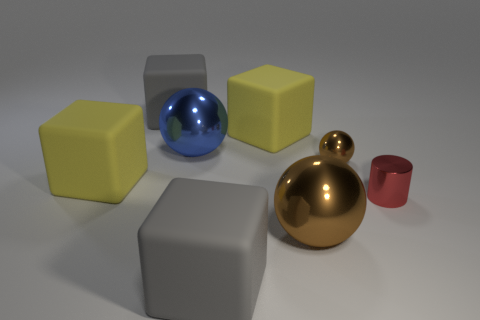Add 1 big red metallic cubes. How many objects exist? 9 Subtract all cylinders. How many objects are left? 7 Add 3 big blue things. How many big blue things are left? 4 Add 2 tiny red metal cylinders. How many tiny red metal cylinders exist? 3 Subtract 0 yellow balls. How many objects are left? 8 Subtract all cylinders. Subtract all brown balls. How many objects are left? 5 